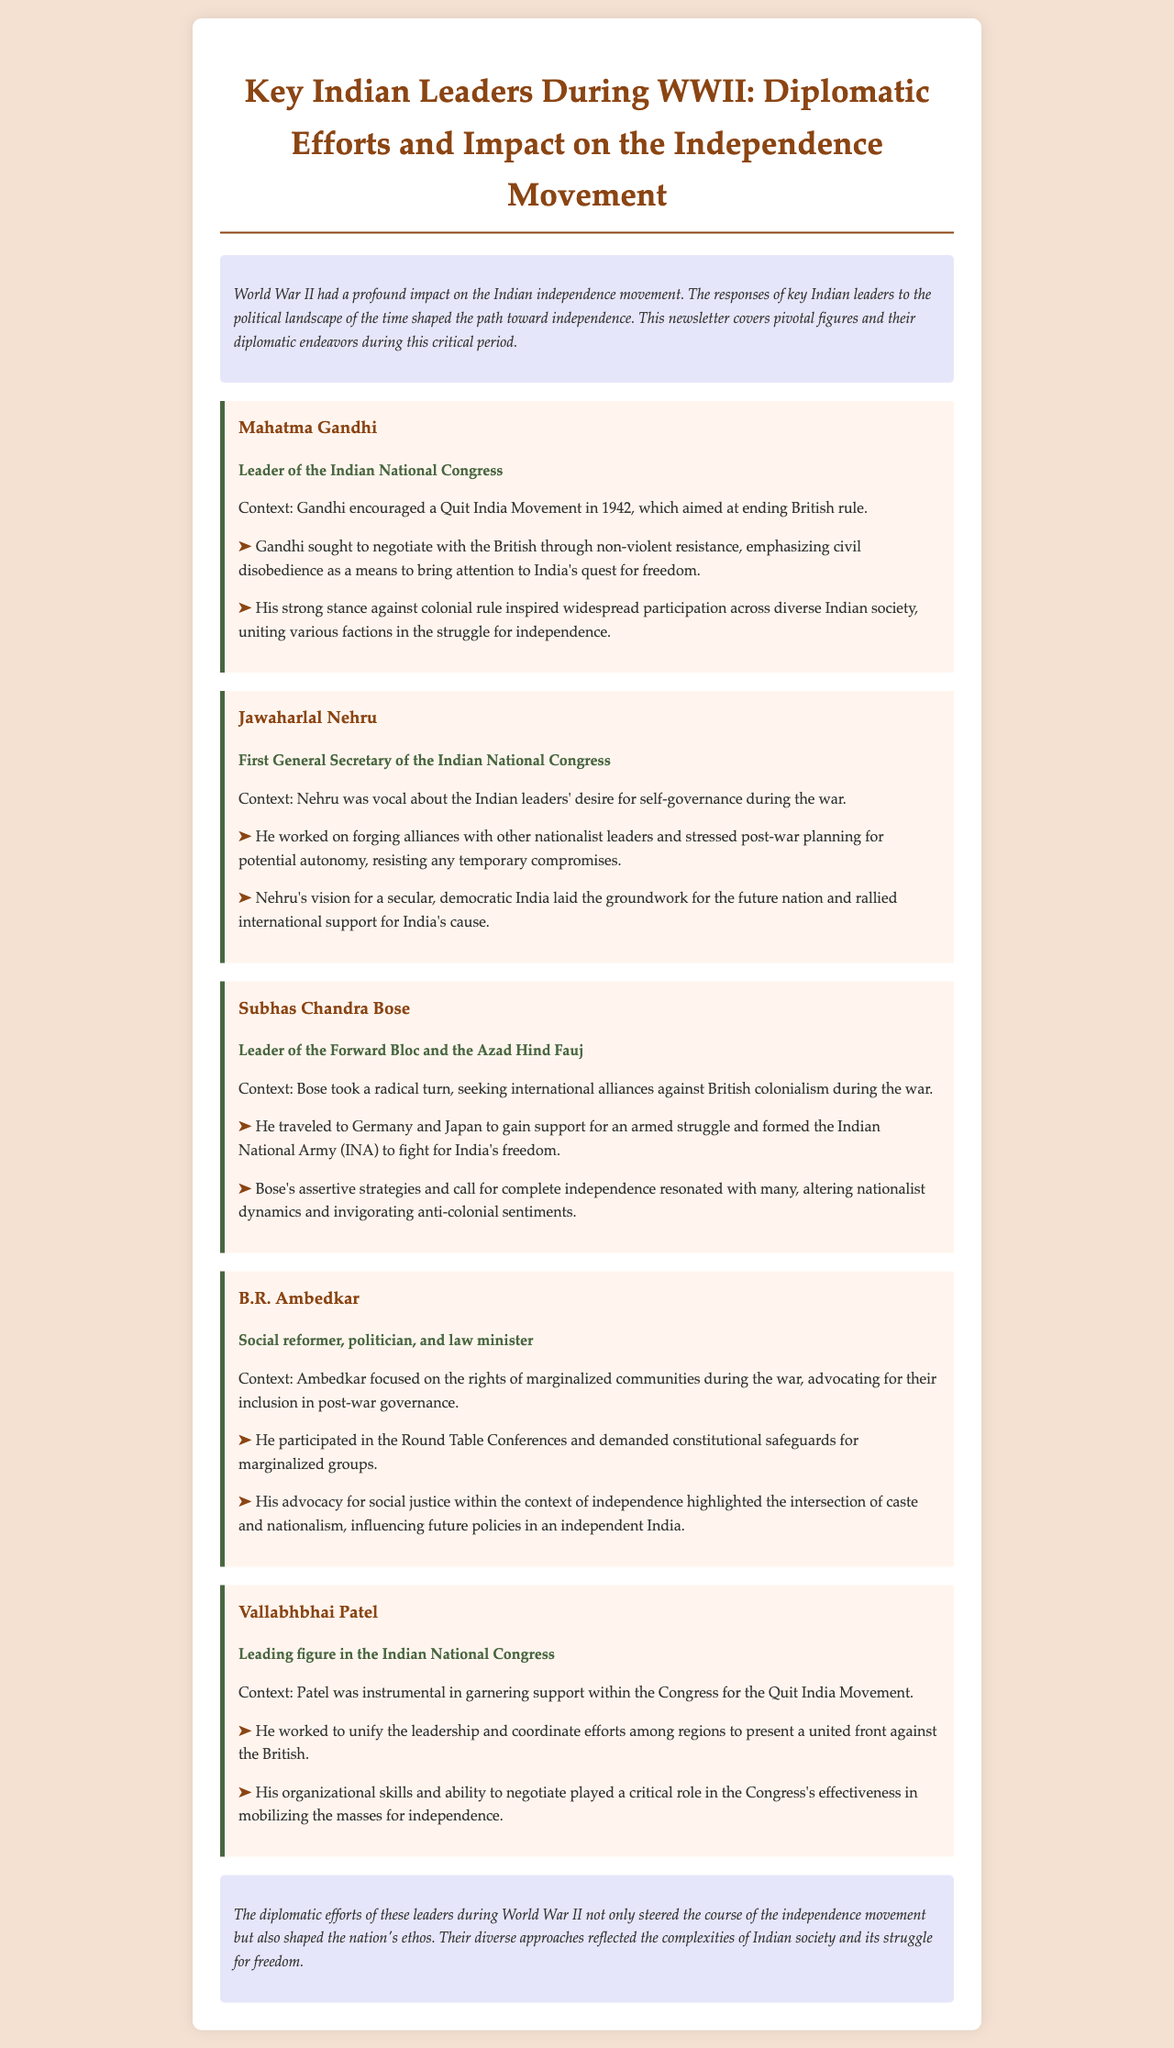What was the objective of the Quit India Movement? The Quit India Movement aimed at ending British rule in India.
Answer: ending British rule Who encouraged the Quit India Movement? Mahatma Gandhi encouraged the Quit India Movement in 1942.
Answer: Mahatma Gandhi What was Jawaharlal Nehru's role during WWII? Nehru was the First General Secretary of the Indian National Congress.
Answer: First General Secretary Which leader formed the Indian National Army? Subhas Chandra Bose formed the Indian National Army (INA).
Answer: Subhas Chandra Bose What did B.R. Ambedkar advocate for during the war? Ambedkar advocated for the rights of marginalized communities.
Answer: rights of marginalized communities What was Vallabhbhai Patel's significant contribution? Patel unified the leadership of the Congress during the Quit India Movement.
Answer: unified the leadership How did Gandhi seek to negotiate with the British? Gandhi emphasized civil disobedience as a means to negotiate.
Answer: civil disobedience Who was known for seeking international alliances against colonialism? Subhas Chandra Bose was known for seeking international alliances.
Answer: Subhas Chandra Bose What did Nehru stress regarding post-war planning? Nehru stressed on planning for potential autonomy.
Answer: planning for potential autonomy 